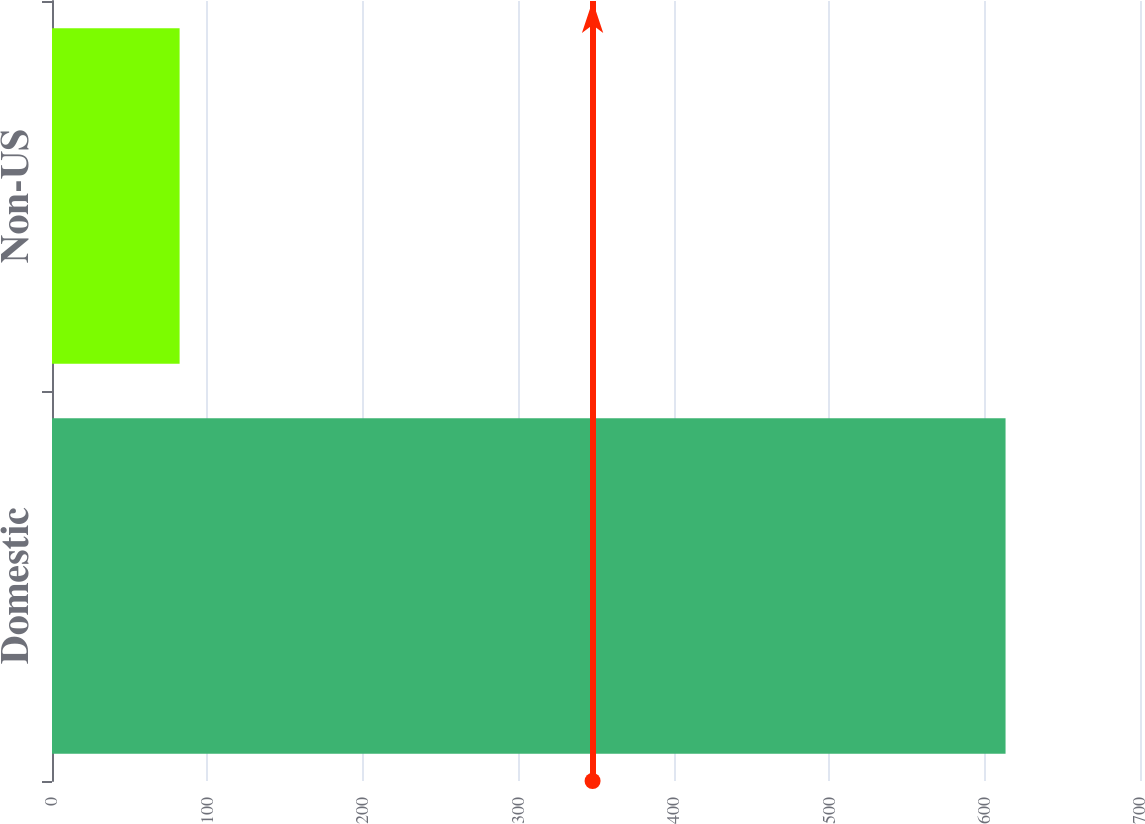Convert chart to OTSL. <chart><loc_0><loc_0><loc_500><loc_500><bar_chart><fcel>Domestic<fcel>Non-US<nl><fcel>613.5<fcel>82.1<nl></chart> 